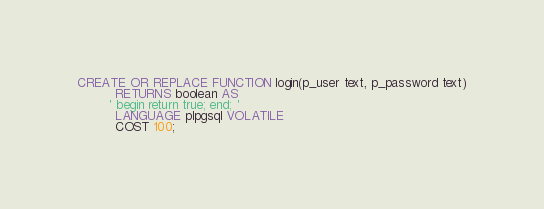<code> <loc_0><loc_0><loc_500><loc_500><_SQL_>CREATE OR REPLACE FUNCTION login(p_user text, p_password text)
          RETURNS boolean AS
        ' begin return true; end; '
          LANGUAGE plpgsql VOLATILE
          COST 100;
</code> 